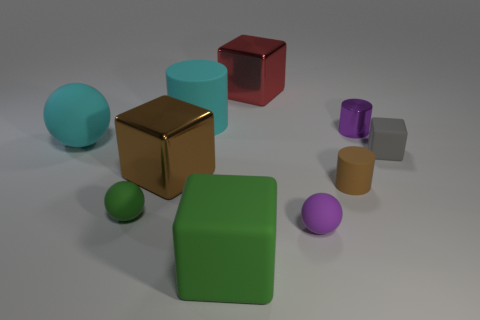There is a rubber object that is the same color as the shiny cylinder; what is its size?
Offer a terse response. Small. What number of other things are there of the same color as the large cylinder?
Give a very brief answer. 1. Does the large cylinder have the same color as the ball behind the gray matte cube?
Make the answer very short. Yes. How many things are either large cyan matte spheres or red metal cubes?
Offer a very short reply. 2. There is a big red object; is it the same shape as the brown thing on the left side of the big green matte object?
Keep it short and to the point. Yes. What shape is the purple object in front of the metal cylinder?
Offer a very short reply. Sphere. Is the shape of the small green object the same as the large red metal thing?
Your answer should be compact. No. What is the size of the cyan object that is the same shape as the tiny brown matte object?
Keep it short and to the point. Large. There is a cyan rubber thing that is in front of the cyan matte cylinder; is it the same size as the small green matte ball?
Keep it short and to the point. No. There is a object that is to the right of the cyan rubber cylinder and behind the small purple metal cylinder; what is its size?
Make the answer very short. Large. 